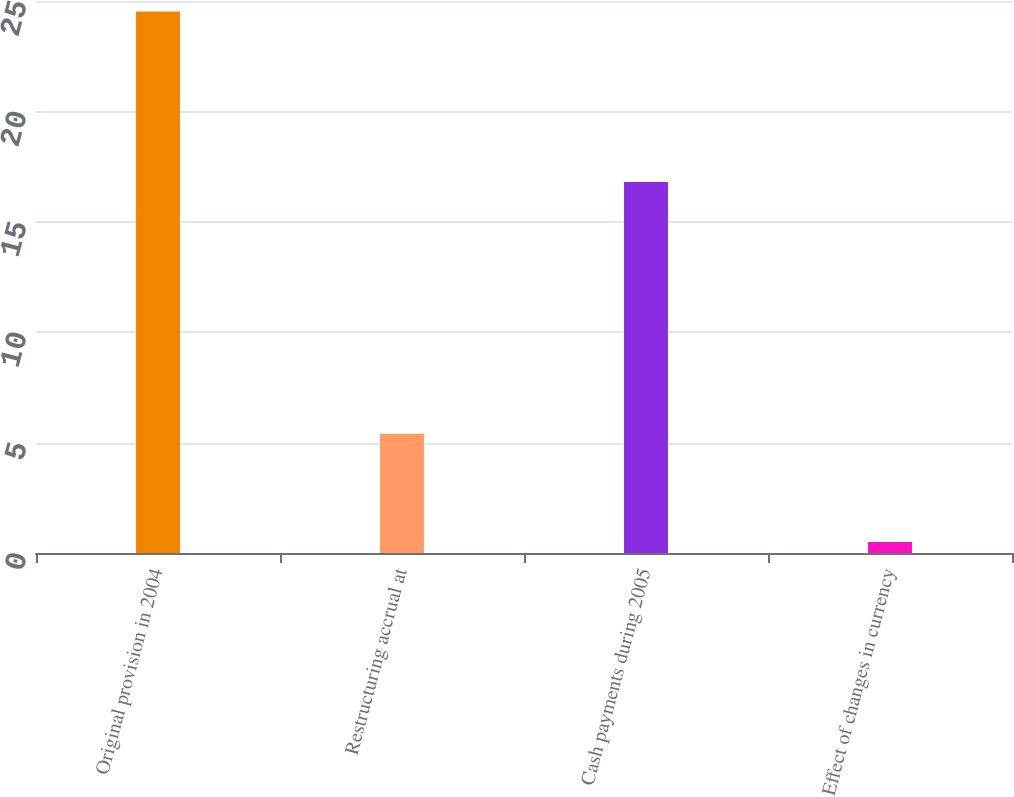Convert chart. <chart><loc_0><loc_0><loc_500><loc_500><bar_chart><fcel>Original provision in 2004<fcel>Restructuring accrual at<fcel>Cash payments during 2005<fcel>Effect of changes in currency<nl><fcel>24.52<fcel>5.4<fcel>16.8<fcel>0.5<nl></chart> 